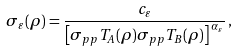<formula> <loc_0><loc_0><loc_500><loc_500>\sigma _ { \varepsilon } ( \rho ) = \frac { c _ { \varepsilon } } { \left [ \sigma _ { p p } T _ { A } ( \rho ) \sigma _ { p p } T _ { B } ( \rho ) \right ] ^ { \, \alpha _ { \varepsilon } } } \, ,</formula> 